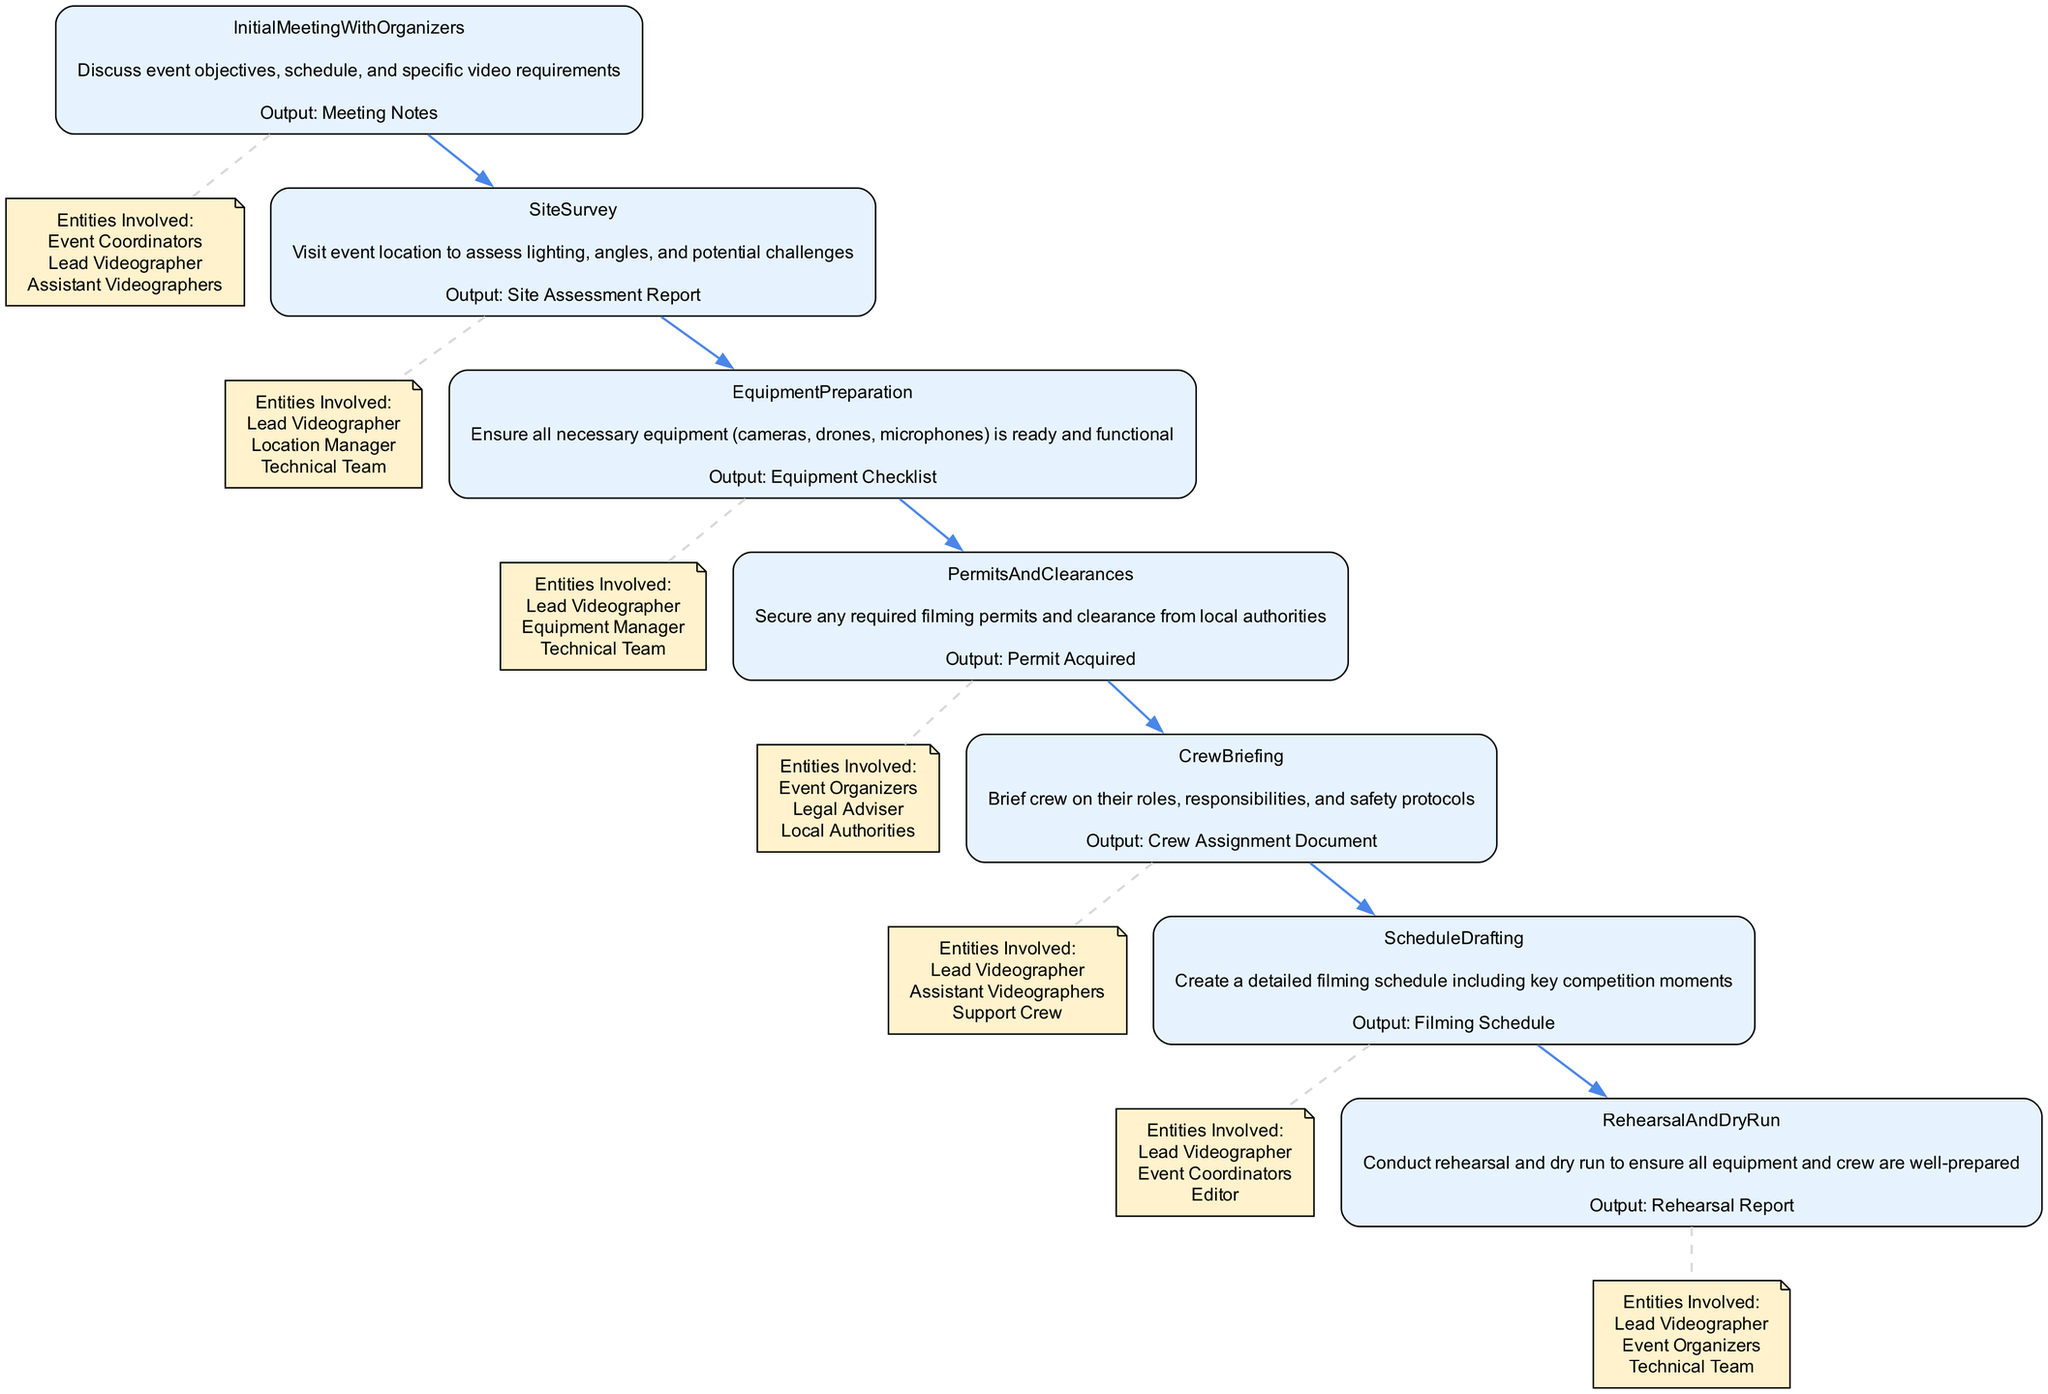What is the output of the Initial Meeting with Organizers? The output for the Initial Meeting with Organizers is "Meeting Notes" as specified in the diagram.
Answer: Meeting Notes How many entities are involved in the Equipment Preparation step? The Equipment Preparation step lists three entities involved: Lead Videographer, Equipment Manager, and Technical Team. Hence, the count is three.
Answer: 3 What comes directly after the Site Survey step in the flow? The flow follows a sequence of steps where the Equipment Preparation step comes directly after the Site Survey step.
Answer: Equipment Preparation Which step requires securing permits and clearances? The step that requires securing permits and clearances is called "Permits And Clearances" as indicated in the diagram.
Answer: Permits And Clearances What is the main purpose of the Crew Briefing step? The Crew Briefing step is meant to brief crew on their roles, responsibilities, and safety protocols, which can be found in the description of the step.
Answer: Briefing on roles, responsibilities, and safety protocols How many total steps are shown in the diagram? The diagram presents a total of seven steps related to pre-event planning and coordination, as there are seven main functions listed.
Answer: 7 What do the entities involved in the Site Survey step include? The entities involved in the Site Survey step are the Lead Videographer, Location Manager, and Technical Team, as specified within that step in the diagram.
Answer: Lead Videographer, Location Manager, Technical Team What is the relationship between the Rehearsal and Dry Run step and the Technical Team? The Rehearsal and Dry Run step involves the Technical Team among other entities, showing a collaborative relationship indicated by their inclusion in the summary of involved parties in that step.
Answer: Collaborating role 